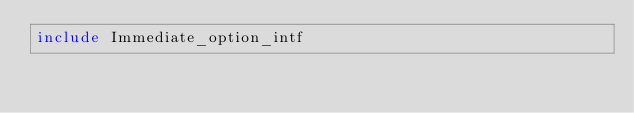<code> <loc_0><loc_0><loc_500><loc_500><_OCaml_>include Immediate_option_intf
</code> 